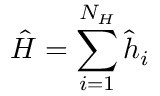Convert formula to latex. <formula><loc_0><loc_0><loc_500><loc_500>\hat { H } = \sum _ { i = 1 } ^ { N _ { H } } \hat { h } _ { i }</formula> 